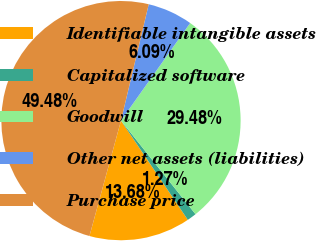Convert chart. <chart><loc_0><loc_0><loc_500><loc_500><pie_chart><fcel>Identifiable intangible assets<fcel>Capitalized software<fcel>Goodwill<fcel>Other net assets (liabilities)<fcel>Purchase price<nl><fcel>13.68%<fcel>1.27%<fcel>29.48%<fcel>6.09%<fcel>49.48%<nl></chart> 